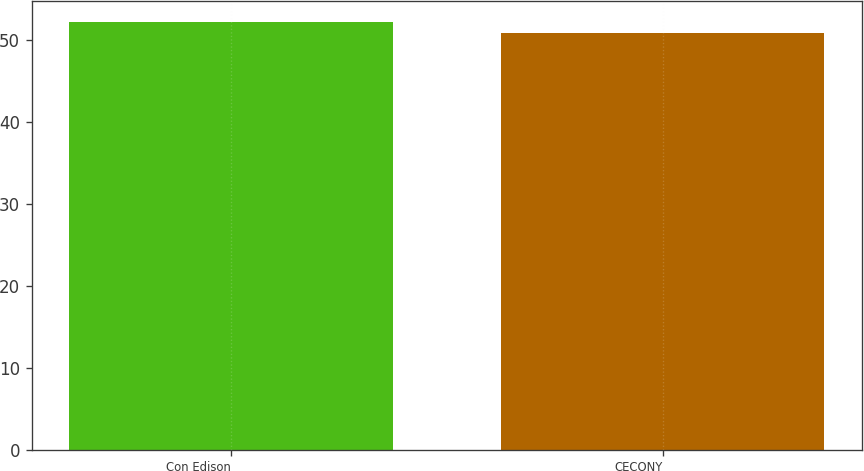Convert chart. <chart><loc_0><loc_0><loc_500><loc_500><bar_chart><fcel>Con Edison<fcel>CECONY<nl><fcel>52.2<fcel>50.9<nl></chart> 